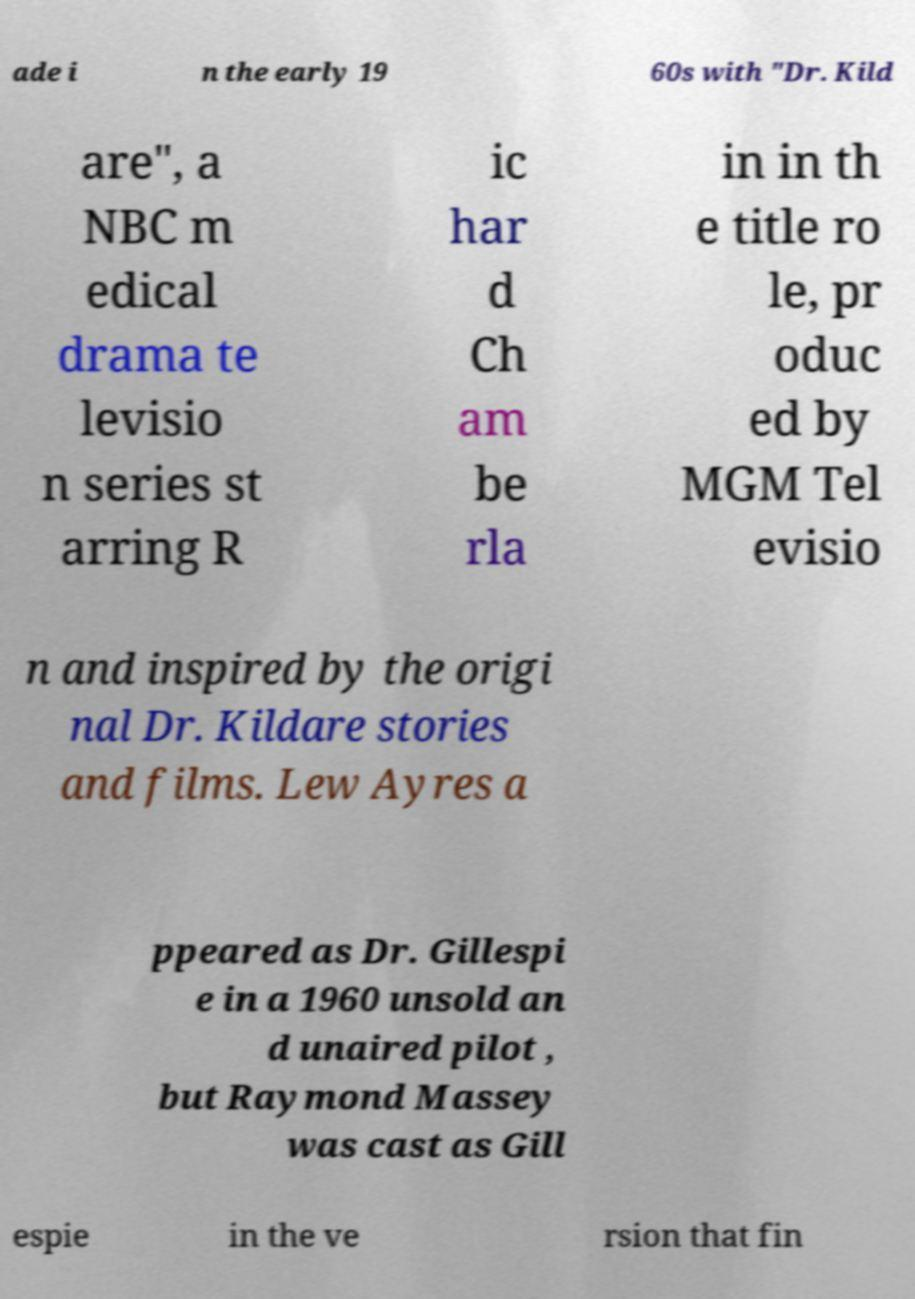What messages or text are displayed in this image? I need them in a readable, typed format. ade i n the early 19 60s with "Dr. Kild are", a NBC m edical drama te levisio n series st arring R ic har d Ch am be rla in in th e title ro le, pr oduc ed by MGM Tel evisio n and inspired by the origi nal Dr. Kildare stories and films. Lew Ayres a ppeared as Dr. Gillespi e in a 1960 unsold an d unaired pilot , but Raymond Massey was cast as Gill espie in the ve rsion that fin 